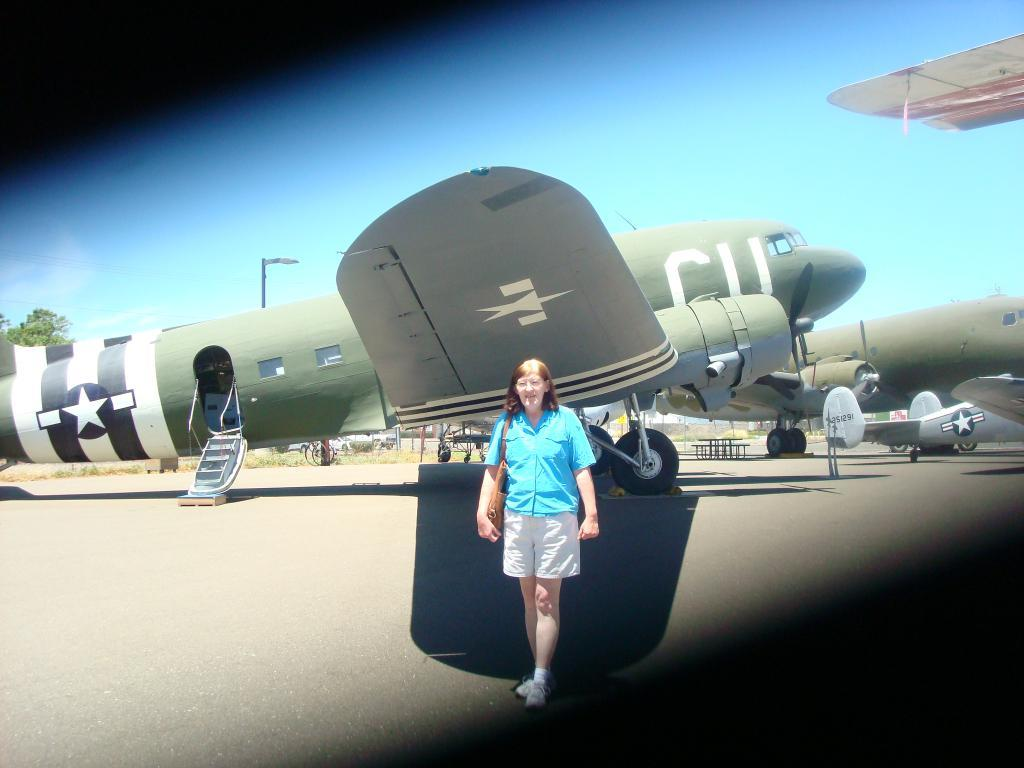<image>
Give a short and clear explanation of the subsequent image. Star logo on a CU Airplane that is green. 